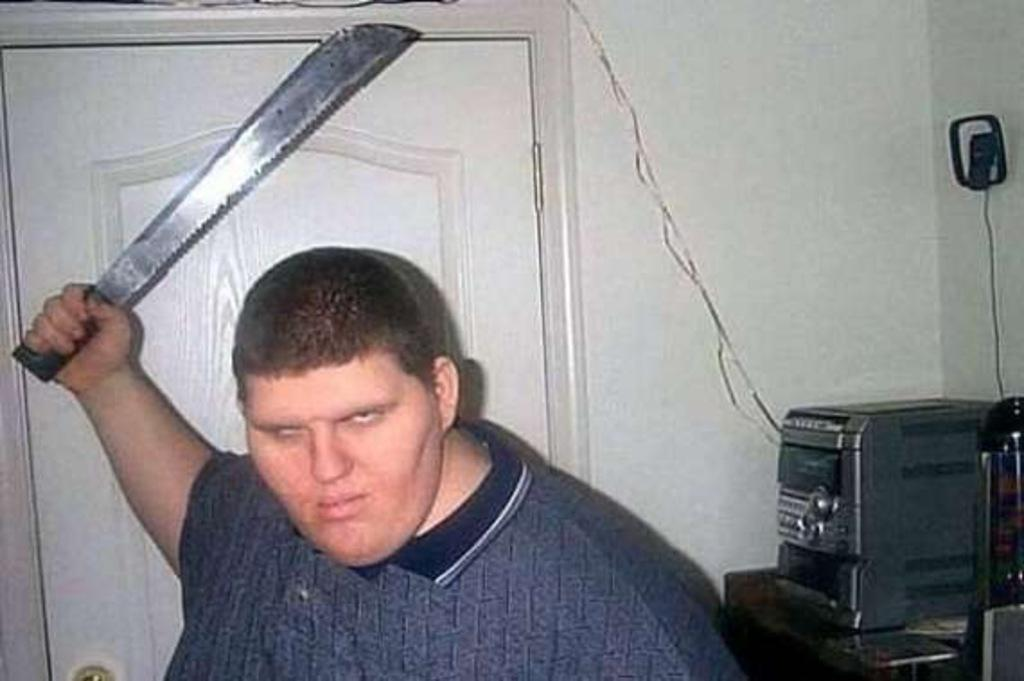What is present in the image? There is a man in the image. What is the man doing in the image? The man is posing to the camera. What object is the man holding in his right hand? The man is raising a knife in his right hand. What type of bears can be seen in the image? There are no bears present in the image. What scent is associated with the mailbox in the image? There is no mailbox present in the image, so it is not possible to determine any associated scent. 